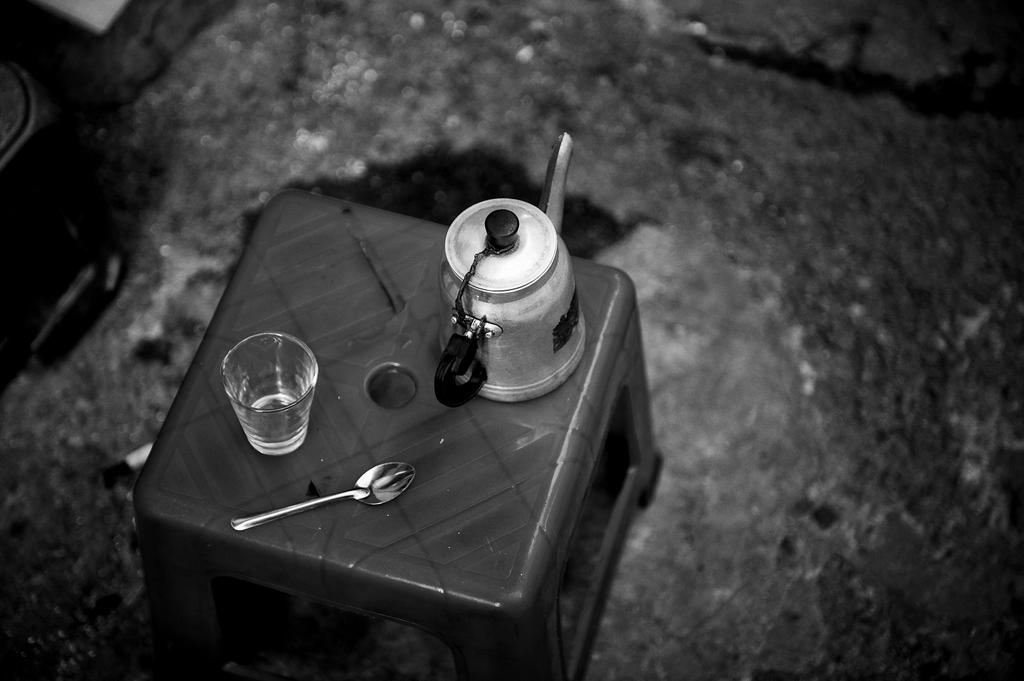What is the main object in the image? There is a teapot in the image. What other objects can be seen in the image? There is a glass and a spoon in the image. What type of furniture is present in the image? There is a stool in the image. Where is the stool located in the image? The stool is on the ground. What type of plants can be seen growing on the teapot in the image? There are no plants growing on the teapot in the image. 